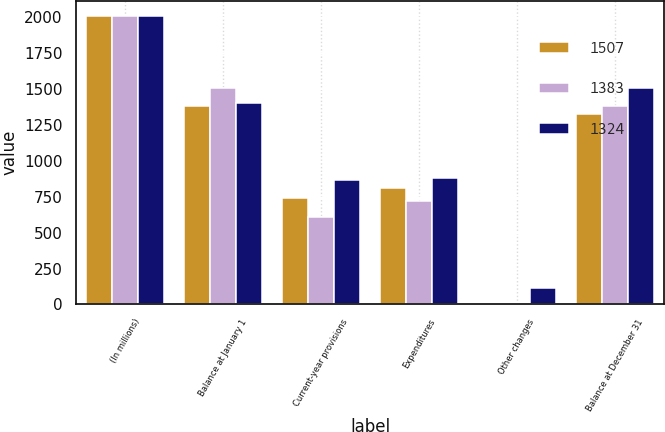Convert chart. <chart><loc_0><loc_0><loc_500><loc_500><stacked_bar_chart><ecel><fcel>(In millions)<fcel>Balance at January 1<fcel>Current-year provisions<fcel>Expenditures<fcel>Other changes<fcel>Balance at December 31<nl><fcel>1507<fcel>2013<fcel>1383<fcel>745<fcel>814<fcel>10<fcel>1324<nl><fcel>1383<fcel>2012<fcel>1507<fcel>611<fcel>723<fcel>12<fcel>1383<nl><fcel>1324<fcel>2011<fcel>1405<fcel>866<fcel>881<fcel>117<fcel>1507<nl></chart> 